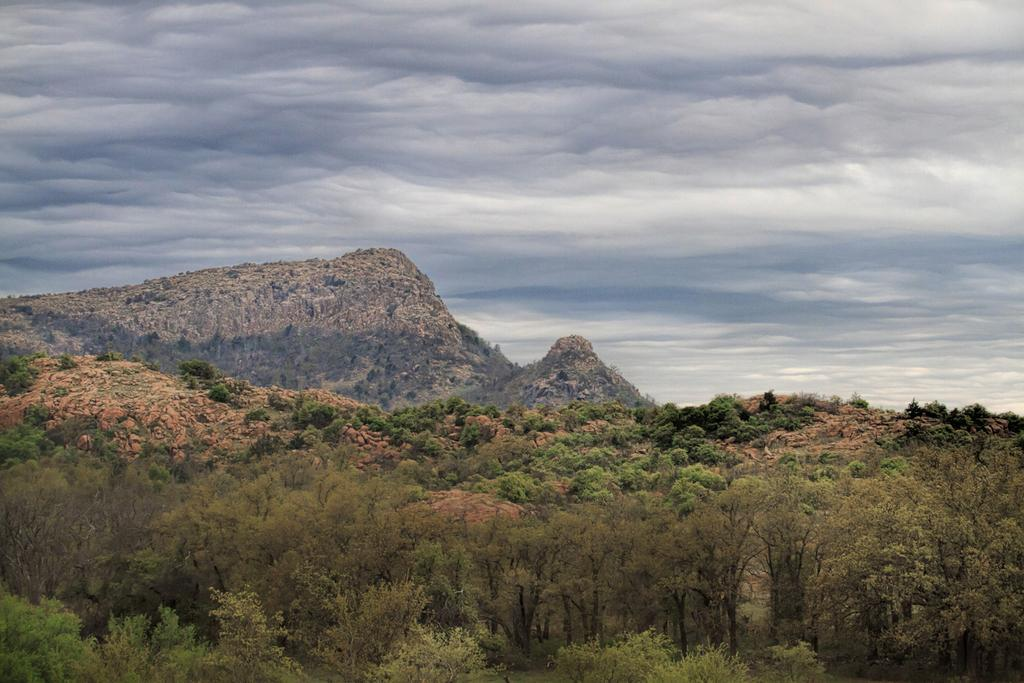What type of vegetation or plants can be seen at the bottom of the image? There is greenery at the bottom of the image. What can be seen at the top of the image? There is sky visible at the top of the image. What type of geographical feature is on the left side of the image? There is a mountain on the left side of the image. What type of peace symbol can be seen on the sidewalk in the image? There is no sidewalk or peace symbol present in the image. What does the mountain look like when viewed from the mouth of the cave? There is no cave or mouth mentioned in the image, so it is not possible to answer that question. 